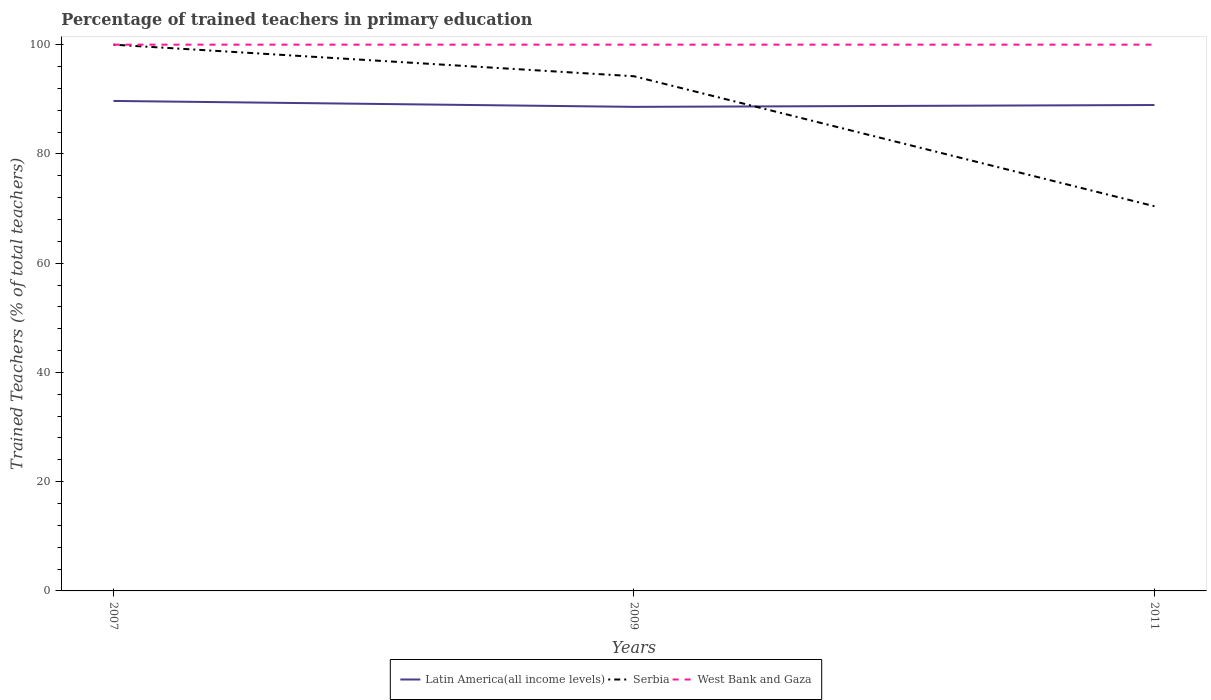How many different coloured lines are there?
Offer a very short reply. 3. Is the number of lines equal to the number of legend labels?
Your answer should be compact. Yes. Across all years, what is the maximum percentage of trained teachers in Latin America(all income levels)?
Offer a very short reply. 88.61. What is the total percentage of trained teachers in West Bank and Gaza in the graph?
Your answer should be compact. 0. Is the percentage of trained teachers in Latin America(all income levels) strictly greater than the percentage of trained teachers in Serbia over the years?
Offer a very short reply. No. What is the difference between two consecutive major ticks on the Y-axis?
Provide a succinct answer. 20. Does the graph contain grids?
Provide a succinct answer. No. How many legend labels are there?
Your answer should be very brief. 3. What is the title of the graph?
Offer a terse response. Percentage of trained teachers in primary education. Does "New Caledonia" appear as one of the legend labels in the graph?
Your response must be concise. No. What is the label or title of the X-axis?
Your answer should be very brief. Years. What is the label or title of the Y-axis?
Your answer should be very brief. Trained Teachers (% of total teachers). What is the Trained Teachers (% of total teachers) in Latin America(all income levels) in 2007?
Make the answer very short. 89.7. What is the Trained Teachers (% of total teachers) of West Bank and Gaza in 2007?
Ensure brevity in your answer.  100. What is the Trained Teachers (% of total teachers) of Latin America(all income levels) in 2009?
Give a very brief answer. 88.61. What is the Trained Teachers (% of total teachers) in Serbia in 2009?
Offer a very short reply. 94.22. What is the Trained Teachers (% of total teachers) in Latin America(all income levels) in 2011?
Give a very brief answer. 88.95. What is the Trained Teachers (% of total teachers) in Serbia in 2011?
Give a very brief answer. 70.42. What is the Trained Teachers (% of total teachers) in West Bank and Gaza in 2011?
Give a very brief answer. 100. Across all years, what is the maximum Trained Teachers (% of total teachers) of Latin America(all income levels)?
Give a very brief answer. 89.7. Across all years, what is the minimum Trained Teachers (% of total teachers) of Latin America(all income levels)?
Provide a short and direct response. 88.61. Across all years, what is the minimum Trained Teachers (% of total teachers) in Serbia?
Your answer should be compact. 70.42. Across all years, what is the minimum Trained Teachers (% of total teachers) of West Bank and Gaza?
Your response must be concise. 100. What is the total Trained Teachers (% of total teachers) in Latin America(all income levels) in the graph?
Give a very brief answer. 267.26. What is the total Trained Teachers (% of total teachers) in Serbia in the graph?
Offer a terse response. 264.64. What is the total Trained Teachers (% of total teachers) in West Bank and Gaza in the graph?
Keep it short and to the point. 300. What is the difference between the Trained Teachers (% of total teachers) in Latin America(all income levels) in 2007 and that in 2009?
Provide a succinct answer. 1.08. What is the difference between the Trained Teachers (% of total teachers) of Serbia in 2007 and that in 2009?
Offer a terse response. 5.78. What is the difference between the Trained Teachers (% of total teachers) of Latin America(all income levels) in 2007 and that in 2011?
Offer a terse response. 0.75. What is the difference between the Trained Teachers (% of total teachers) of Serbia in 2007 and that in 2011?
Your answer should be very brief. 29.58. What is the difference between the Trained Teachers (% of total teachers) of West Bank and Gaza in 2007 and that in 2011?
Your answer should be compact. 0. What is the difference between the Trained Teachers (% of total teachers) of Latin America(all income levels) in 2009 and that in 2011?
Keep it short and to the point. -0.34. What is the difference between the Trained Teachers (% of total teachers) of Serbia in 2009 and that in 2011?
Your answer should be compact. 23.8. What is the difference between the Trained Teachers (% of total teachers) in Latin America(all income levels) in 2007 and the Trained Teachers (% of total teachers) in Serbia in 2009?
Your answer should be compact. -4.52. What is the difference between the Trained Teachers (% of total teachers) in Latin America(all income levels) in 2007 and the Trained Teachers (% of total teachers) in West Bank and Gaza in 2009?
Offer a terse response. -10.3. What is the difference between the Trained Teachers (% of total teachers) of Latin America(all income levels) in 2007 and the Trained Teachers (% of total teachers) of Serbia in 2011?
Provide a short and direct response. 19.28. What is the difference between the Trained Teachers (% of total teachers) of Latin America(all income levels) in 2007 and the Trained Teachers (% of total teachers) of West Bank and Gaza in 2011?
Your answer should be compact. -10.3. What is the difference between the Trained Teachers (% of total teachers) of Latin America(all income levels) in 2009 and the Trained Teachers (% of total teachers) of Serbia in 2011?
Your answer should be very brief. 18.19. What is the difference between the Trained Teachers (% of total teachers) of Latin America(all income levels) in 2009 and the Trained Teachers (% of total teachers) of West Bank and Gaza in 2011?
Make the answer very short. -11.39. What is the difference between the Trained Teachers (% of total teachers) in Serbia in 2009 and the Trained Teachers (% of total teachers) in West Bank and Gaza in 2011?
Offer a very short reply. -5.78. What is the average Trained Teachers (% of total teachers) in Latin America(all income levels) per year?
Provide a succinct answer. 89.09. What is the average Trained Teachers (% of total teachers) in Serbia per year?
Keep it short and to the point. 88.21. In the year 2007, what is the difference between the Trained Teachers (% of total teachers) of Latin America(all income levels) and Trained Teachers (% of total teachers) of Serbia?
Your response must be concise. -10.3. In the year 2007, what is the difference between the Trained Teachers (% of total teachers) of Latin America(all income levels) and Trained Teachers (% of total teachers) of West Bank and Gaza?
Keep it short and to the point. -10.3. In the year 2009, what is the difference between the Trained Teachers (% of total teachers) of Latin America(all income levels) and Trained Teachers (% of total teachers) of Serbia?
Your response must be concise. -5.61. In the year 2009, what is the difference between the Trained Teachers (% of total teachers) of Latin America(all income levels) and Trained Teachers (% of total teachers) of West Bank and Gaza?
Ensure brevity in your answer.  -11.39. In the year 2009, what is the difference between the Trained Teachers (% of total teachers) of Serbia and Trained Teachers (% of total teachers) of West Bank and Gaza?
Your answer should be compact. -5.78. In the year 2011, what is the difference between the Trained Teachers (% of total teachers) of Latin America(all income levels) and Trained Teachers (% of total teachers) of Serbia?
Your answer should be compact. 18.53. In the year 2011, what is the difference between the Trained Teachers (% of total teachers) in Latin America(all income levels) and Trained Teachers (% of total teachers) in West Bank and Gaza?
Give a very brief answer. -11.05. In the year 2011, what is the difference between the Trained Teachers (% of total teachers) of Serbia and Trained Teachers (% of total teachers) of West Bank and Gaza?
Make the answer very short. -29.58. What is the ratio of the Trained Teachers (% of total teachers) of Latin America(all income levels) in 2007 to that in 2009?
Your answer should be compact. 1.01. What is the ratio of the Trained Teachers (% of total teachers) in Serbia in 2007 to that in 2009?
Your response must be concise. 1.06. What is the ratio of the Trained Teachers (% of total teachers) of Latin America(all income levels) in 2007 to that in 2011?
Offer a very short reply. 1.01. What is the ratio of the Trained Teachers (% of total teachers) in Serbia in 2007 to that in 2011?
Ensure brevity in your answer.  1.42. What is the ratio of the Trained Teachers (% of total teachers) of West Bank and Gaza in 2007 to that in 2011?
Provide a short and direct response. 1. What is the ratio of the Trained Teachers (% of total teachers) of Serbia in 2009 to that in 2011?
Give a very brief answer. 1.34. What is the difference between the highest and the second highest Trained Teachers (% of total teachers) of Latin America(all income levels)?
Your answer should be compact. 0.75. What is the difference between the highest and the second highest Trained Teachers (% of total teachers) of Serbia?
Make the answer very short. 5.78. What is the difference between the highest and the lowest Trained Teachers (% of total teachers) of Latin America(all income levels)?
Give a very brief answer. 1.08. What is the difference between the highest and the lowest Trained Teachers (% of total teachers) of Serbia?
Provide a short and direct response. 29.58. What is the difference between the highest and the lowest Trained Teachers (% of total teachers) in West Bank and Gaza?
Your answer should be compact. 0. 